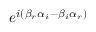<formula> <loc_0><loc_0><loc_500><loc_500>e ^ { i ( \beta _ { r } \alpha _ { i } - \beta _ { i } \alpha _ { r } ) }</formula> 